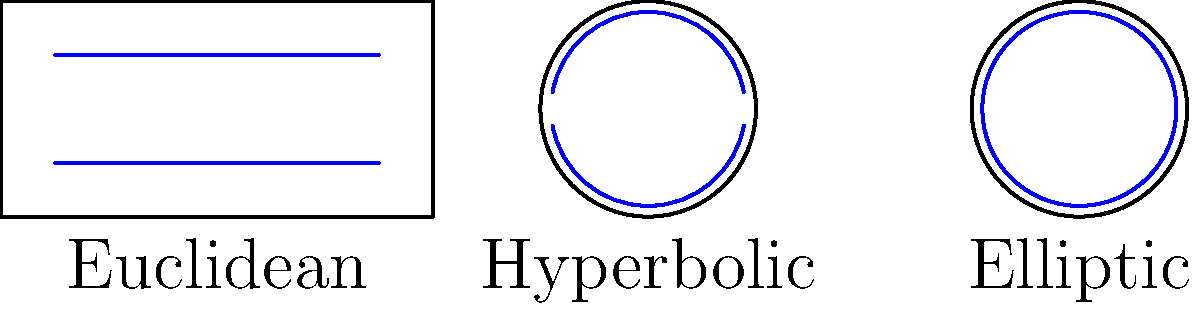In the diagram above, parallel lines are represented in blue for three different geometries. Based on this visual representation, which non-Euclidean geometry allows for parallel lines to intersect, and how does this differ from Euclidean geometry? To answer this question, let's analyze each geometry represented in the diagram:

1. Euclidean geometry:
   - Parallel lines are straight and never intersect.
   - They maintain a constant distance from each other.

2. Hyperbolic geometry (Poincaré disk model):
   - Parallel lines curve away from each other.
   - They diverge and never intersect.

3. Elliptic geometry (represented on a sphere):
   - Lines are represented as great circles.
   - All lines intersect at two antipodal points.

The key difference is in the elliptic geometry, where parallel lines (great circles) always intersect. This is fundamentally different from Euclidean geometry, where parallel lines never intersect.

In elliptic geometry, the concept of parallelism doesn't exist in the same way as in Euclidean geometry. Any two great circles on a sphere will always intersect at two points, which are antipodal (directly opposite) to each other.

This property of elliptic geometry has important implications for data analysis in spherical coordinate systems, such as global positioning and geographical data analysis.
Answer: Elliptic geometry; parallel lines intersect, unlike in Euclidean geometry where they never meet. 